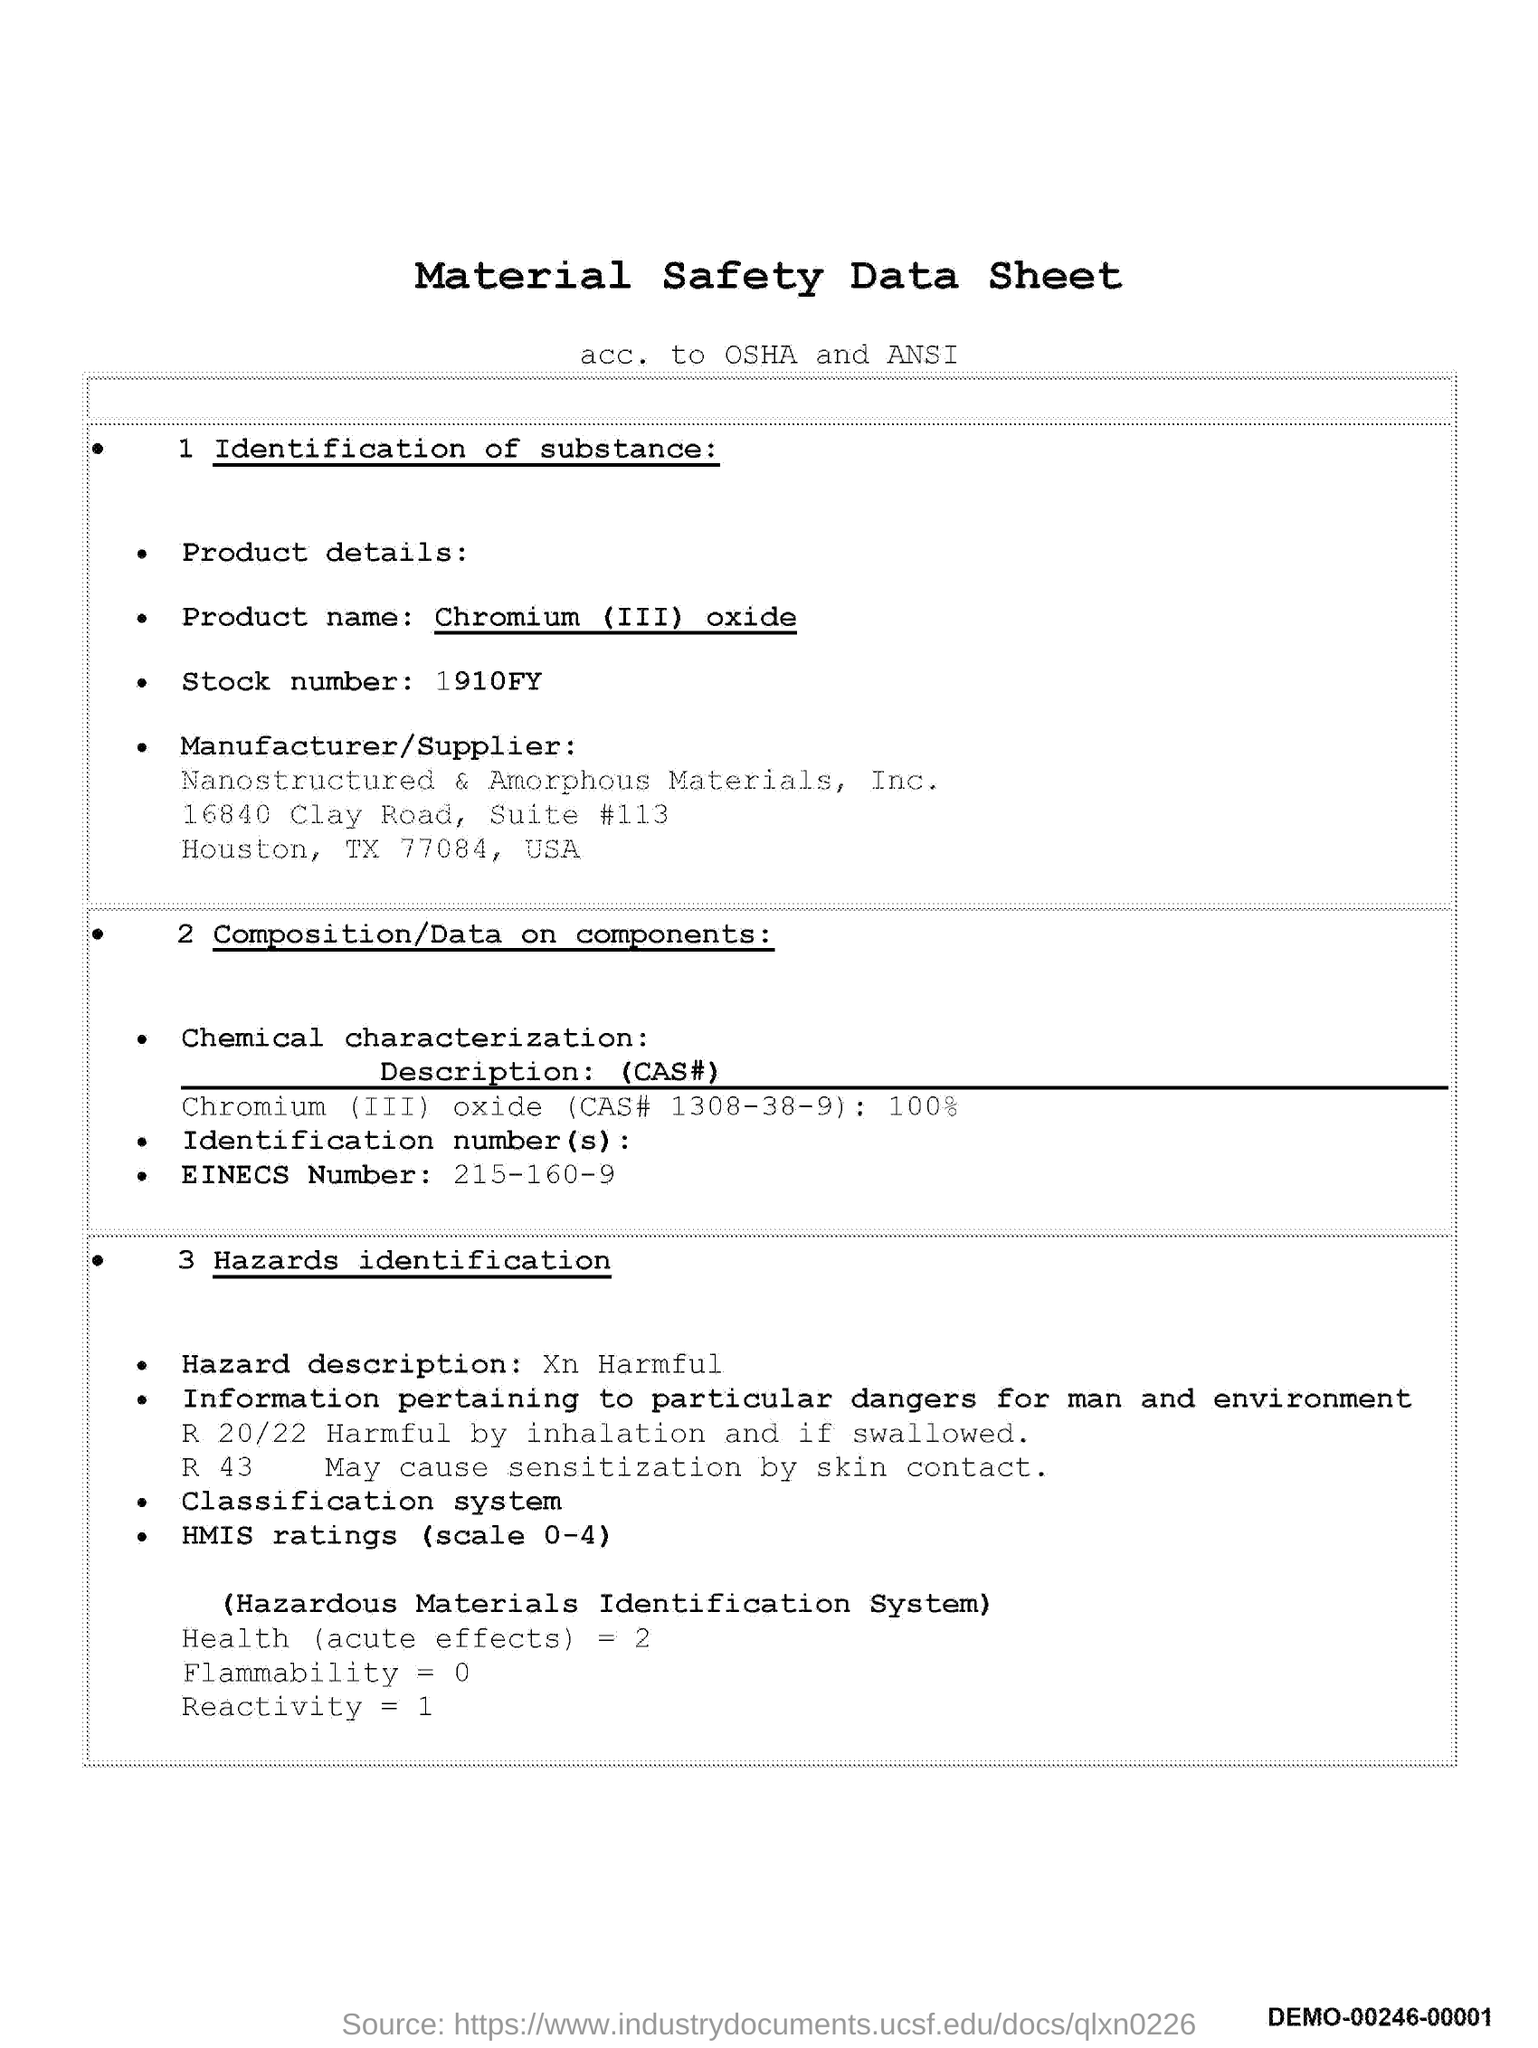Point out several critical features in this image. The title of the document is "Material Safety Data Sheet. What is the stock number? It is 1910FY... The EINECS number is 215-160-9. 